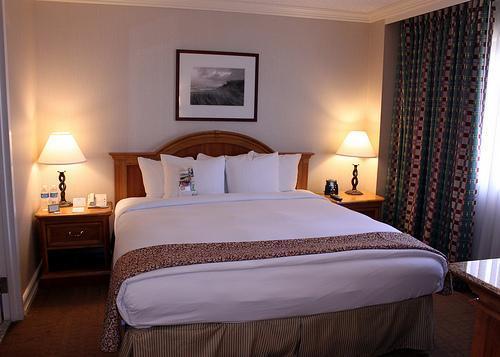How many lamps are shown?
Give a very brief answer. 2. How many pillows are on the bed?
Give a very brief answer. 5. 